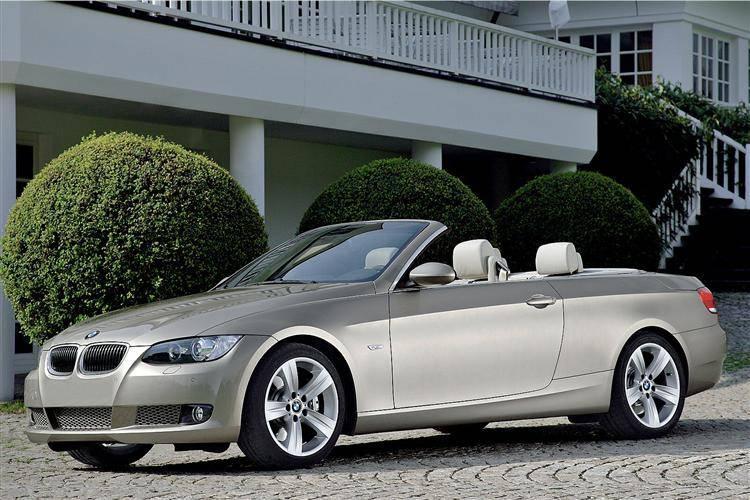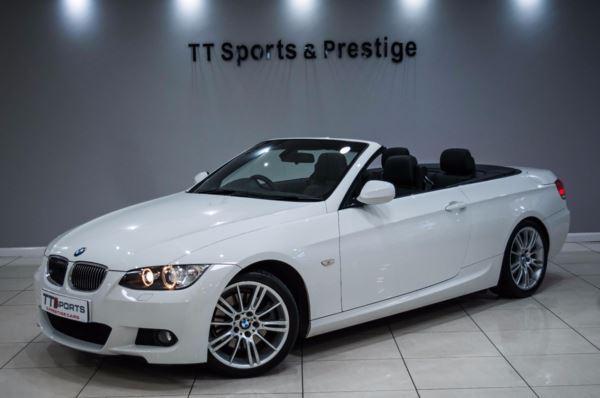The first image is the image on the left, the second image is the image on the right. Evaluate the accuracy of this statement regarding the images: "both pictures have convertibles in them". Is it true? Answer yes or no. Yes. The first image is the image on the left, the second image is the image on the right. Assess this claim about the two images: "there is a man standing next to a car in one of the images.". Correct or not? Answer yes or no. No. 